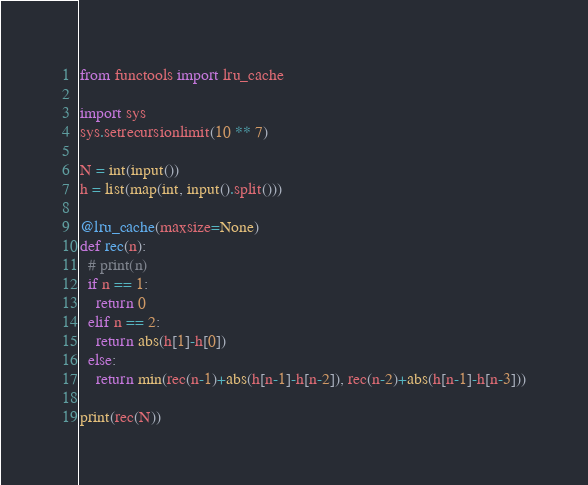<code> <loc_0><loc_0><loc_500><loc_500><_Python_>from functools import lru_cache

import sys
sys.setrecursionlimit(10 ** 7)

N = int(input())
h = list(map(int, input().split()))

@lru_cache(maxsize=None)
def rec(n):
  # print(n)
  if n == 1:
    return 0
  elif n == 2:
    return abs(h[1]-h[0])
  else:
    return min(rec(n-1)+abs(h[n-1]-h[n-2]), rec(n-2)+abs(h[n-1]-h[n-3]))

print(rec(N))</code> 